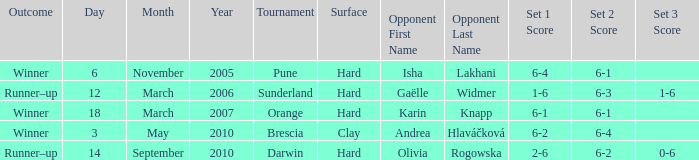What kind of surface was the tournament at Pune played on? Hard. 